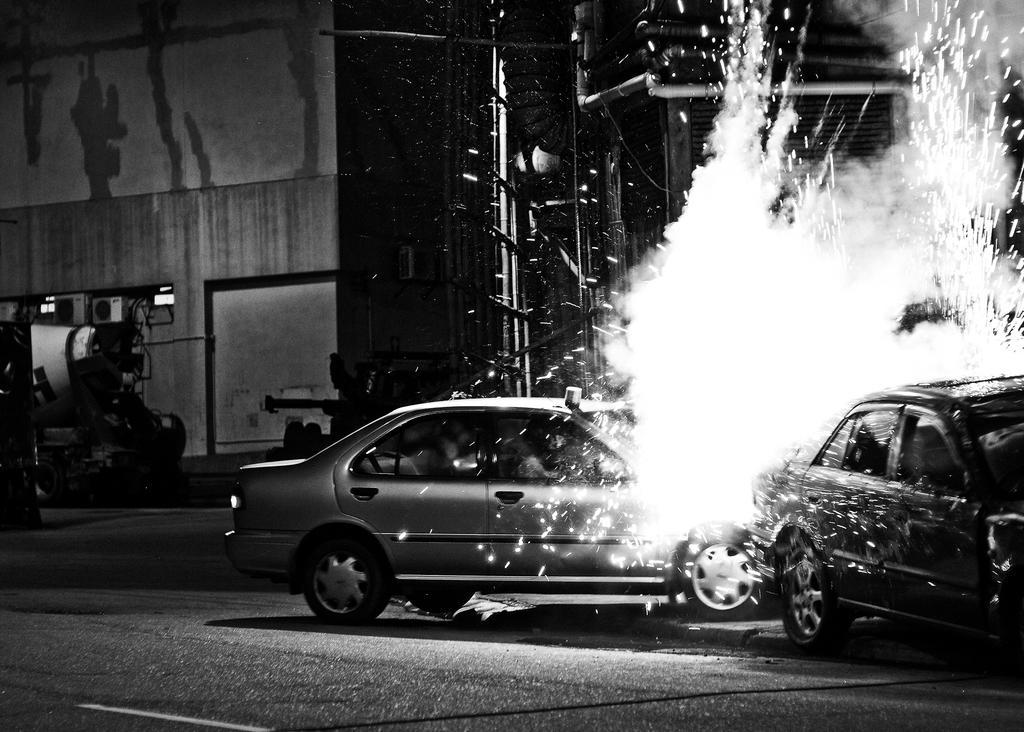In one or two sentences, can you explain what this image depicts? In this image I can see two cars and a fire on the road. In the background I can see buildings, light poles and metal rods. This image is taken may be on the road. 